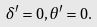Convert formula to latex. <formula><loc_0><loc_0><loc_500><loc_500>\delta ^ { \prime } = 0 , \theta ^ { \prime } = 0 .</formula> 